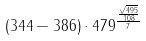Convert formula to latex. <formula><loc_0><loc_0><loc_500><loc_500>( 3 4 4 - 3 8 6 ) \cdot 4 7 9 ^ { \frac { \frac { \sqrt { 4 9 5 } } { 1 0 8 } } { 7 } }</formula> 